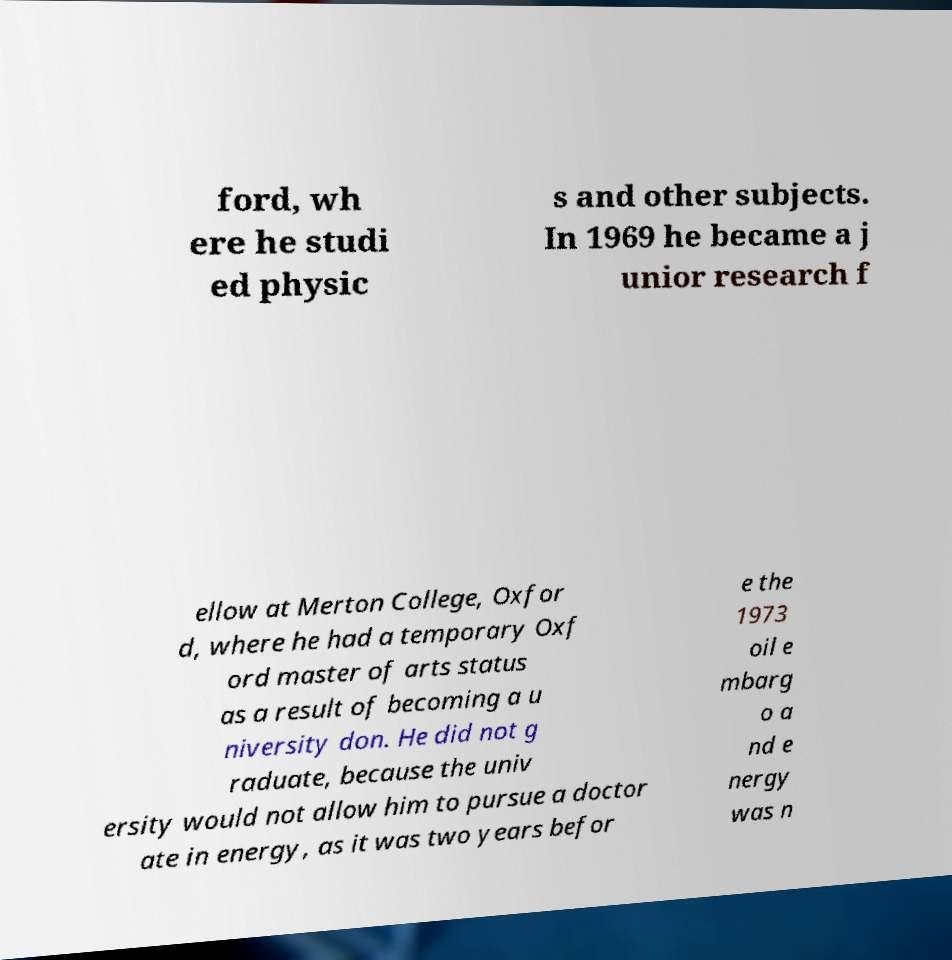Can you accurately transcribe the text from the provided image for me? ford, wh ere he studi ed physic s and other subjects. In 1969 he became a j unior research f ellow at Merton College, Oxfor d, where he had a temporary Oxf ord master of arts status as a result of becoming a u niversity don. He did not g raduate, because the univ ersity would not allow him to pursue a doctor ate in energy, as it was two years befor e the 1973 oil e mbarg o a nd e nergy was n 